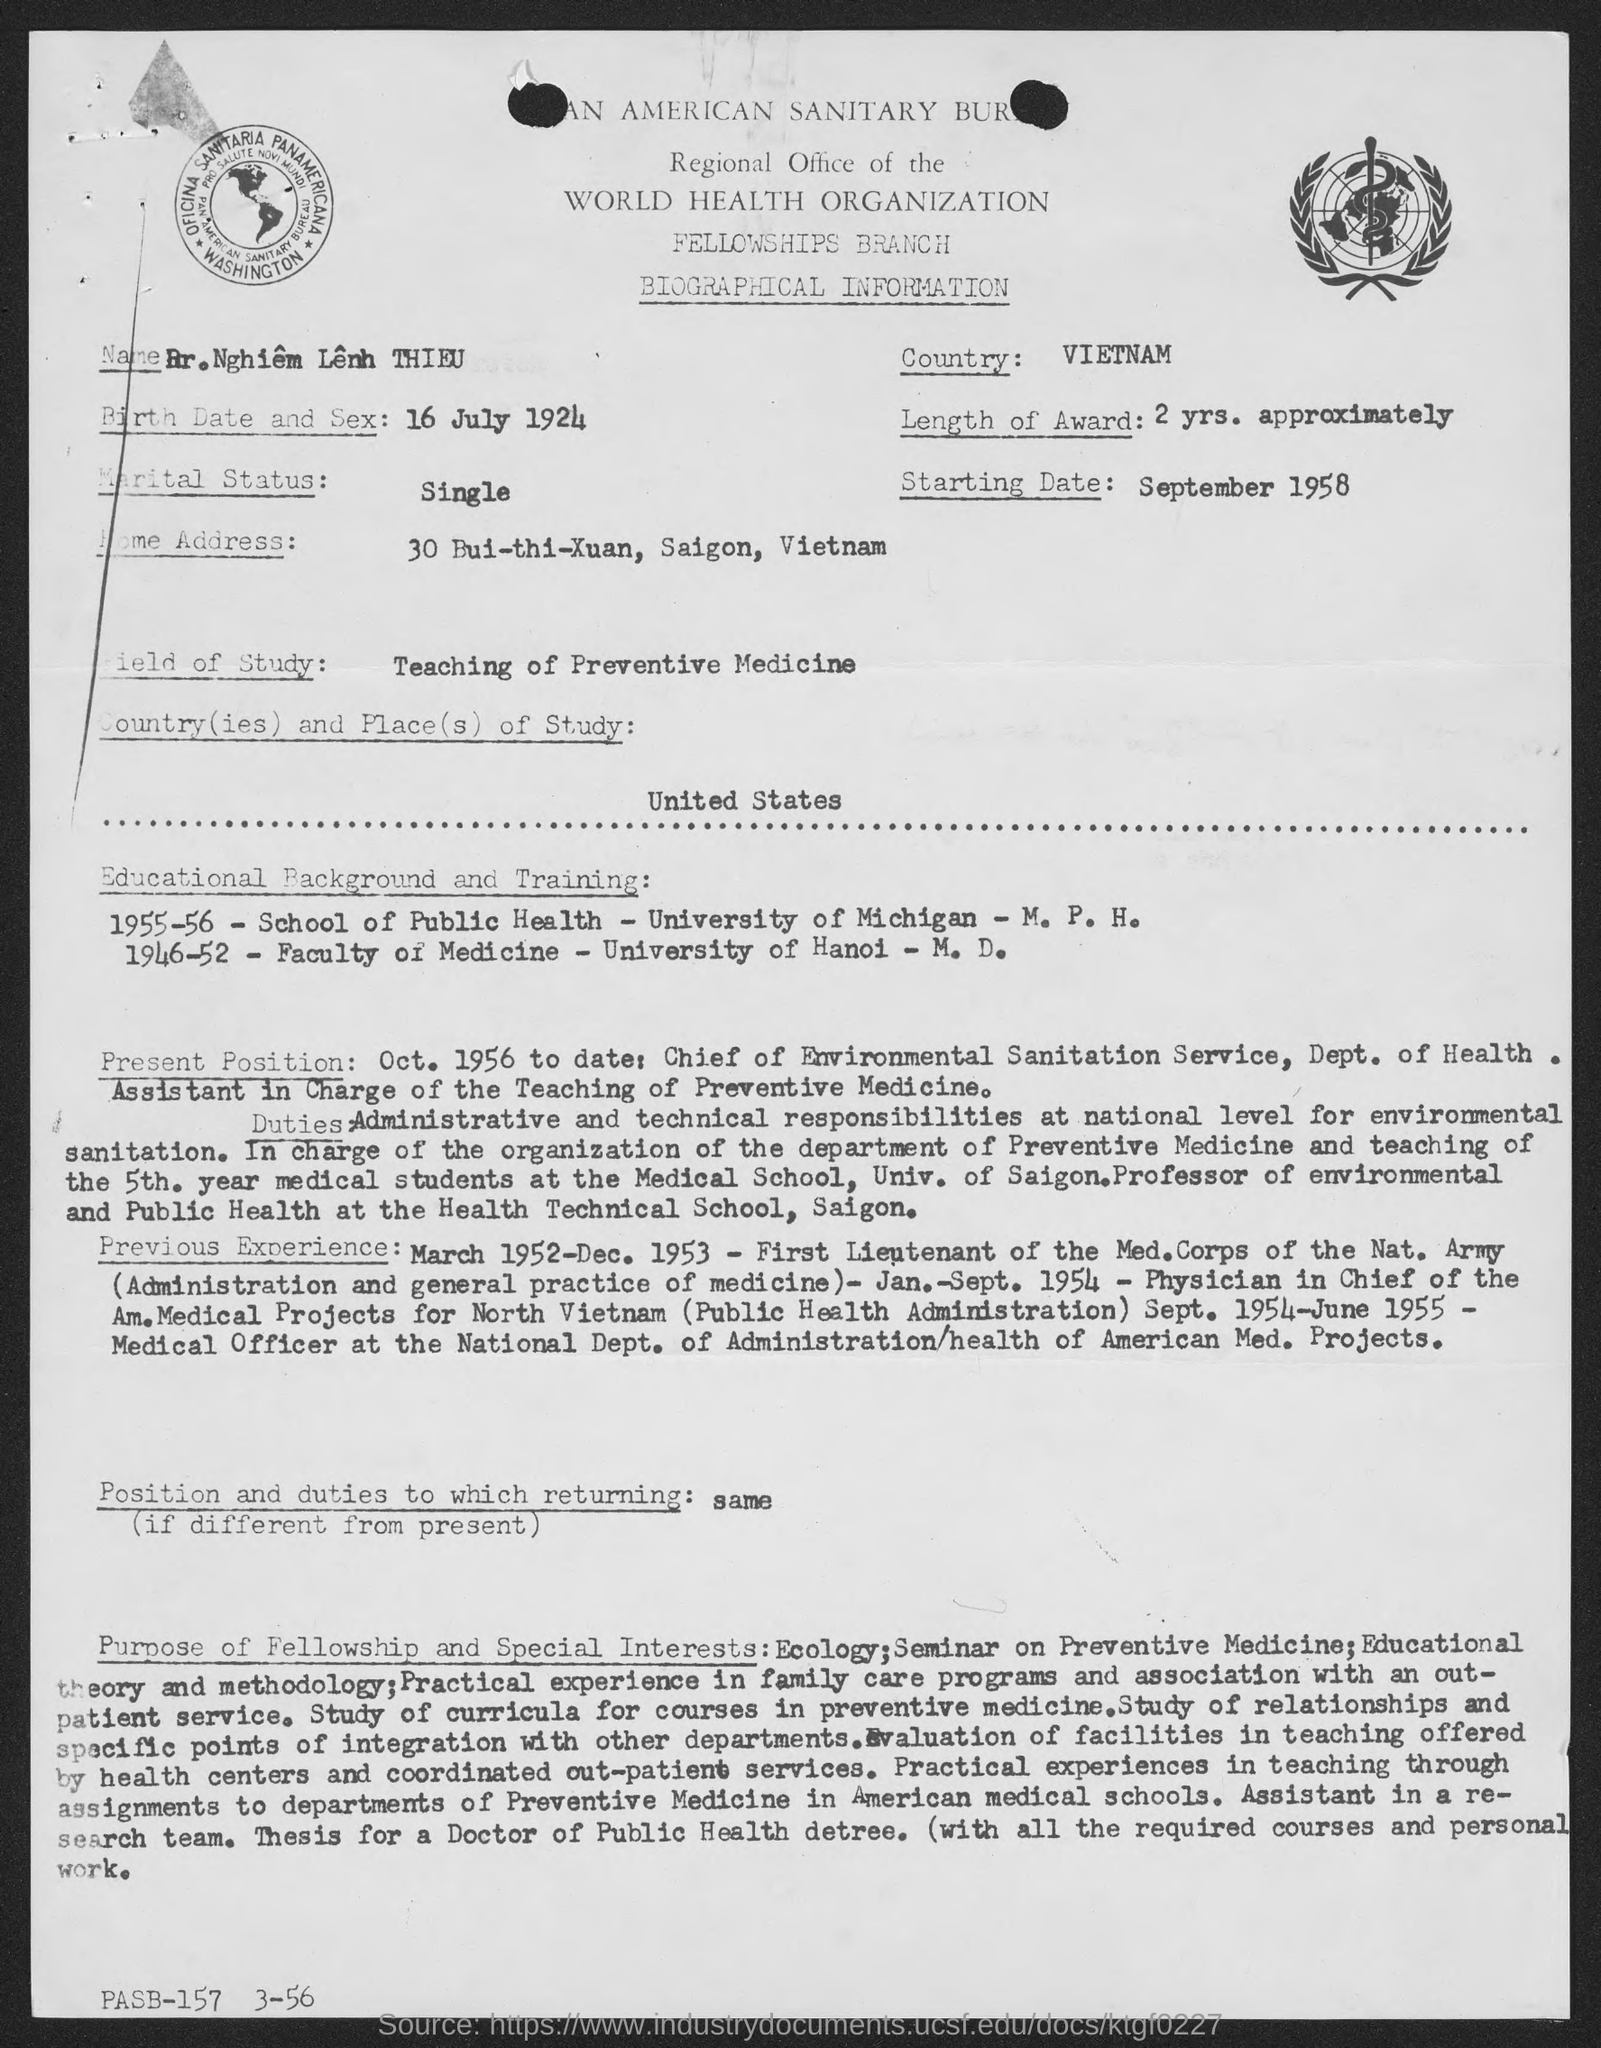Draw attention to some important aspects in this diagram. Dr. Nghiem Lenh THIEU is a citizen of Vietnam. The document provides the starting date of September 1958. Dr. Nghiem Lenh THIEU completed his M.D. degree at the University of Hanoi. Dr. Nghiem Lenh THIEU's marital status is single. Dr. Nghiem Lenh THIEU obtained his M.P.H. degree from the University of Michigan during the year 1955-56. 